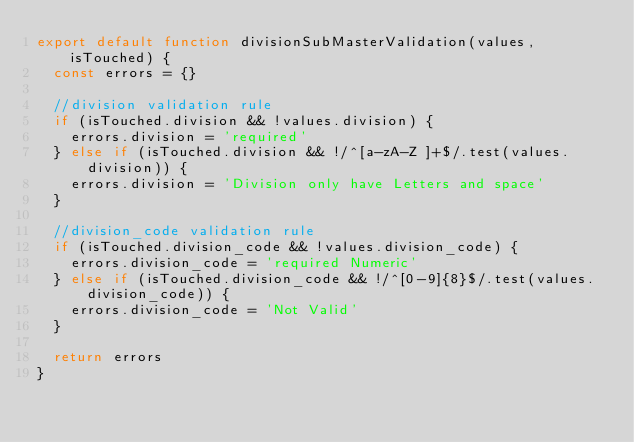Convert code to text. <code><loc_0><loc_0><loc_500><loc_500><_JavaScript_>export default function divisionSubMasterValidation(values, isTouched) {
  const errors = {}

  //division validation rule
  if (isTouched.division && !values.division) {
    errors.division = 'required'
  } else if (isTouched.division && !/^[a-zA-Z ]+$/.test(values.division)) {
    errors.division = 'Division only have Letters and space'
  }

  //division_code validation rule
  if (isTouched.division_code && !values.division_code) {
    errors.division_code = 'required Numeric'
  } else if (isTouched.division_code && !/^[0-9]{8}$/.test(values.division_code)) {
    errors.division_code = 'Not Valid'
  }

  return errors
}
</code> 